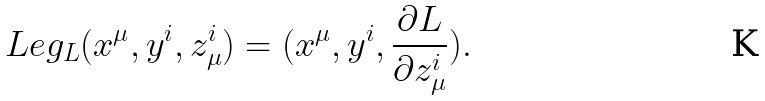<formula> <loc_0><loc_0><loc_500><loc_500>L e g _ { L } ( x ^ { \mu } , y ^ { i } , z ^ { i } _ { \mu } ) = ( x ^ { \mu } , y ^ { i } , \frac { \partial L } { \partial z ^ { i } _ { \mu } } ) .</formula> 